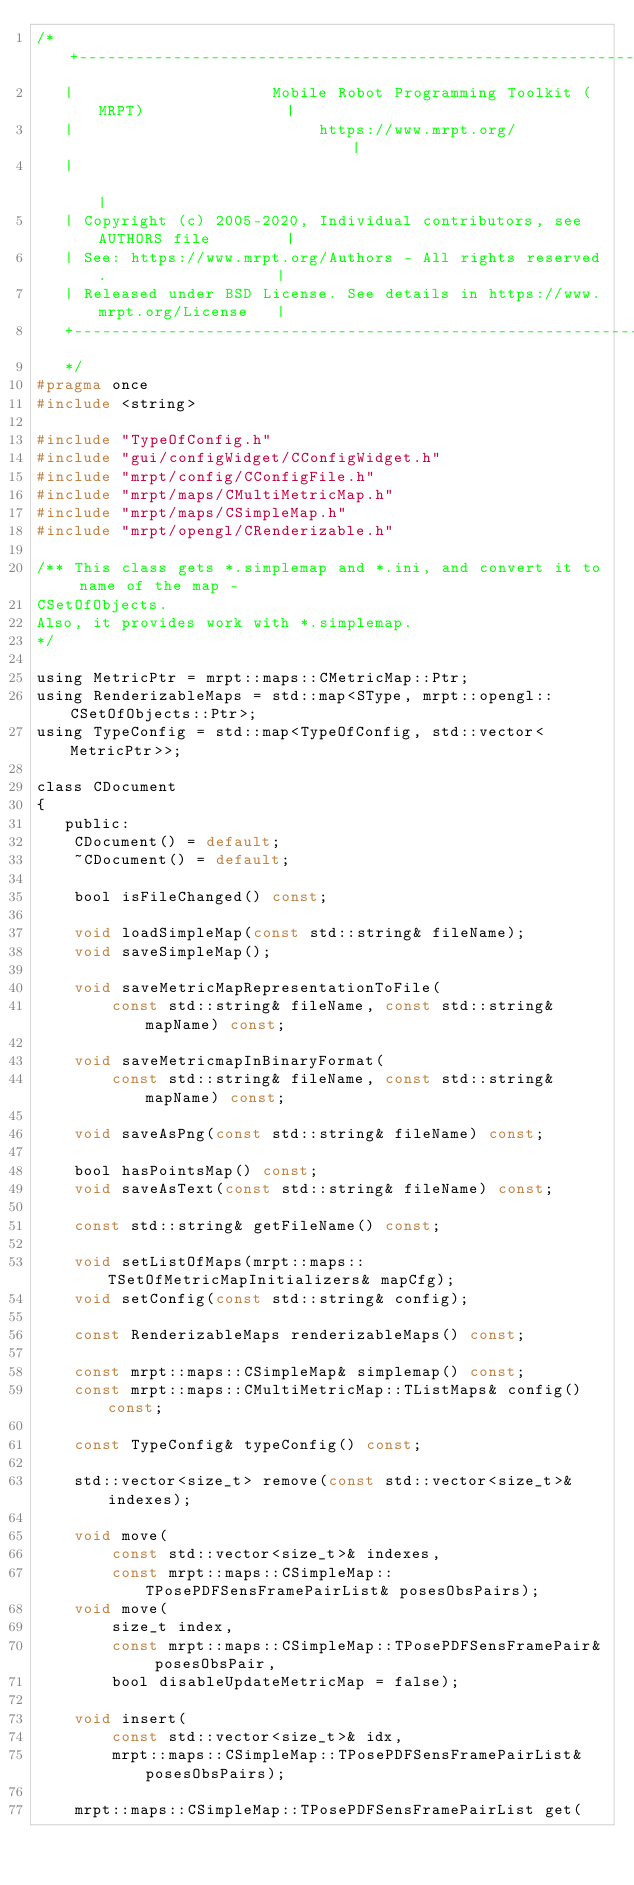Convert code to text. <code><loc_0><loc_0><loc_500><loc_500><_C_>/* +---------------------------------------------------------------------------+
   |                     Mobile Robot Programming Toolkit (MRPT)               |
   |                          https://www.mrpt.org/                            |
   |                                                                           |
   | Copyright (c) 2005-2020, Individual contributors, see AUTHORS file        |
   | See: https://www.mrpt.org/Authors - All rights reserved.                  |
   | Released under BSD License. See details in https://www.mrpt.org/License   |
   +---------------------------------------------------------------------------+
   */
#pragma once
#include <string>

#include "TypeOfConfig.h"
#include "gui/configWidget/CConfigWidget.h"
#include "mrpt/config/CConfigFile.h"
#include "mrpt/maps/CMultiMetricMap.h"
#include "mrpt/maps/CSimpleMap.h"
#include "mrpt/opengl/CRenderizable.h"

/** This class gets *.simplemap and *.ini, and convert it to name of the map -
CSetOfObjects.
Also, it provides work with *.simplemap.
*/

using MetricPtr = mrpt::maps::CMetricMap::Ptr;
using RenderizableMaps = std::map<SType, mrpt::opengl::CSetOfObjects::Ptr>;
using TypeConfig = std::map<TypeOfConfig, std::vector<MetricPtr>>;

class CDocument
{
   public:
	CDocument() = default;
	~CDocument() = default;

	bool isFileChanged() const;

	void loadSimpleMap(const std::string& fileName);
	void saveSimpleMap();

	void saveMetricMapRepresentationToFile(
		const std::string& fileName, const std::string& mapName) const;

	void saveMetricmapInBinaryFormat(
		const std::string& fileName, const std::string& mapName) const;

	void saveAsPng(const std::string& fileName) const;

	bool hasPointsMap() const;
	void saveAsText(const std::string& fileName) const;

	const std::string& getFileName() const;

	void setListOfMaps(mrpt::maps::TSetOfMetricMapInitializers& mapCfg);
	void setConfig(const std::string& config);

	const RenderizableMaps renderizableMaps() const;

	const mrpt::maps::CSimpleMap& simplemap() const;
	const mrpt::maps::CMultiMetricMap::TListMaps& config() const;

	const TypeConfig& typeConfig() const;

	std::vector<size_t> remove(const std::vector<size_t>& indexes);

	void move(
		const std::vector<size_t>& indexes,
		const mrpt::maps::CSimpleMap::TPosePDFSensFramePairList& posesObsPairs);
	void move(
		size_t index,
		const mrpt::maps::CSimpleMap::TPosePDFSensFramePair& posesObsPair,
		bool disableUpdateMetricMap = false);

	void insert(
		const std::vector<size_t>& idx,
		mrpt::maps::CSimpleMap::TPosePDFSensFramePairList& posesObsPairs);

	mrpt::maps::CSimpleMap::TPosePDFSensFramePairList get(</code> 